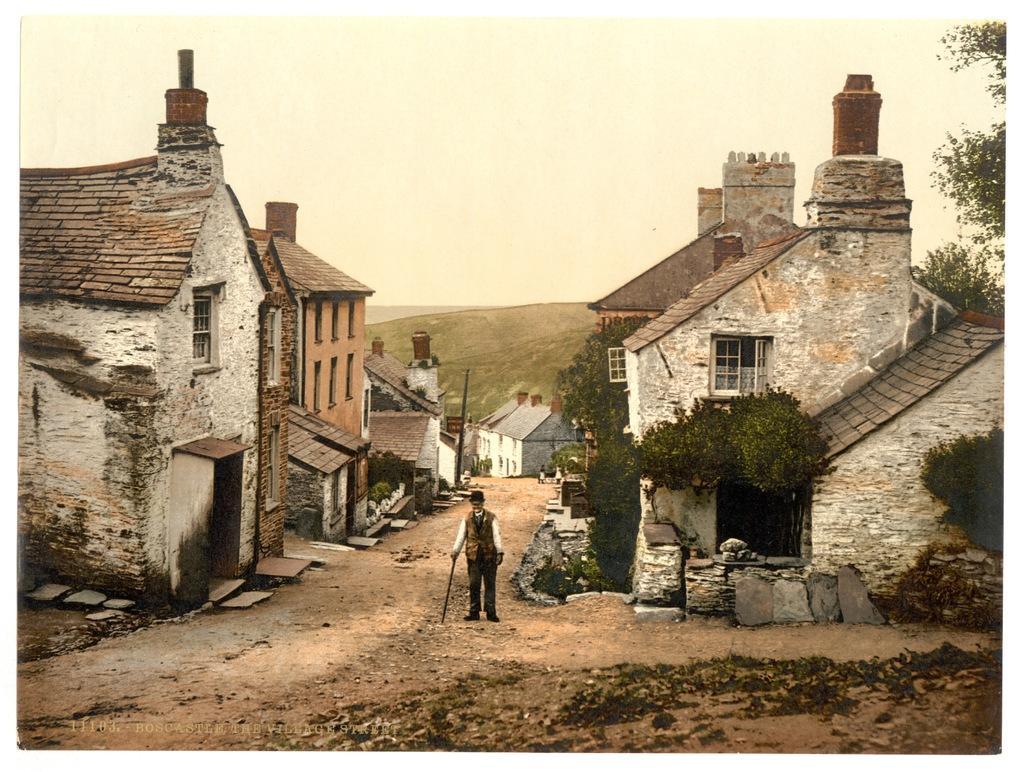Describe this image in one or two sentences. There is a man standing and holding stick and wore hat. We can see houses and trees. On the background we can see hill and sky. 